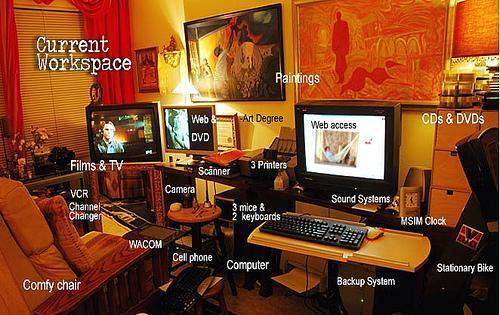How many keyboards are in the photo?
Give a very brief answer. 1. How many tvs are there?
Give a very brief answer. 3. 